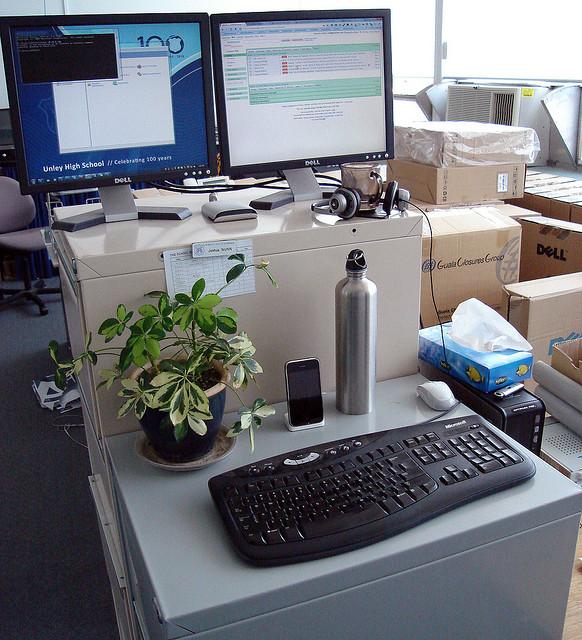What color is the keyboard?
Write a very short answer. Black. What is in the bottle on the far right?
Be succinct. Water. What is in the blue box to the right of the keyboard?
Write a very short answer. Tissues. What brand of keyboard is this?
Concise answer only. Dell. 